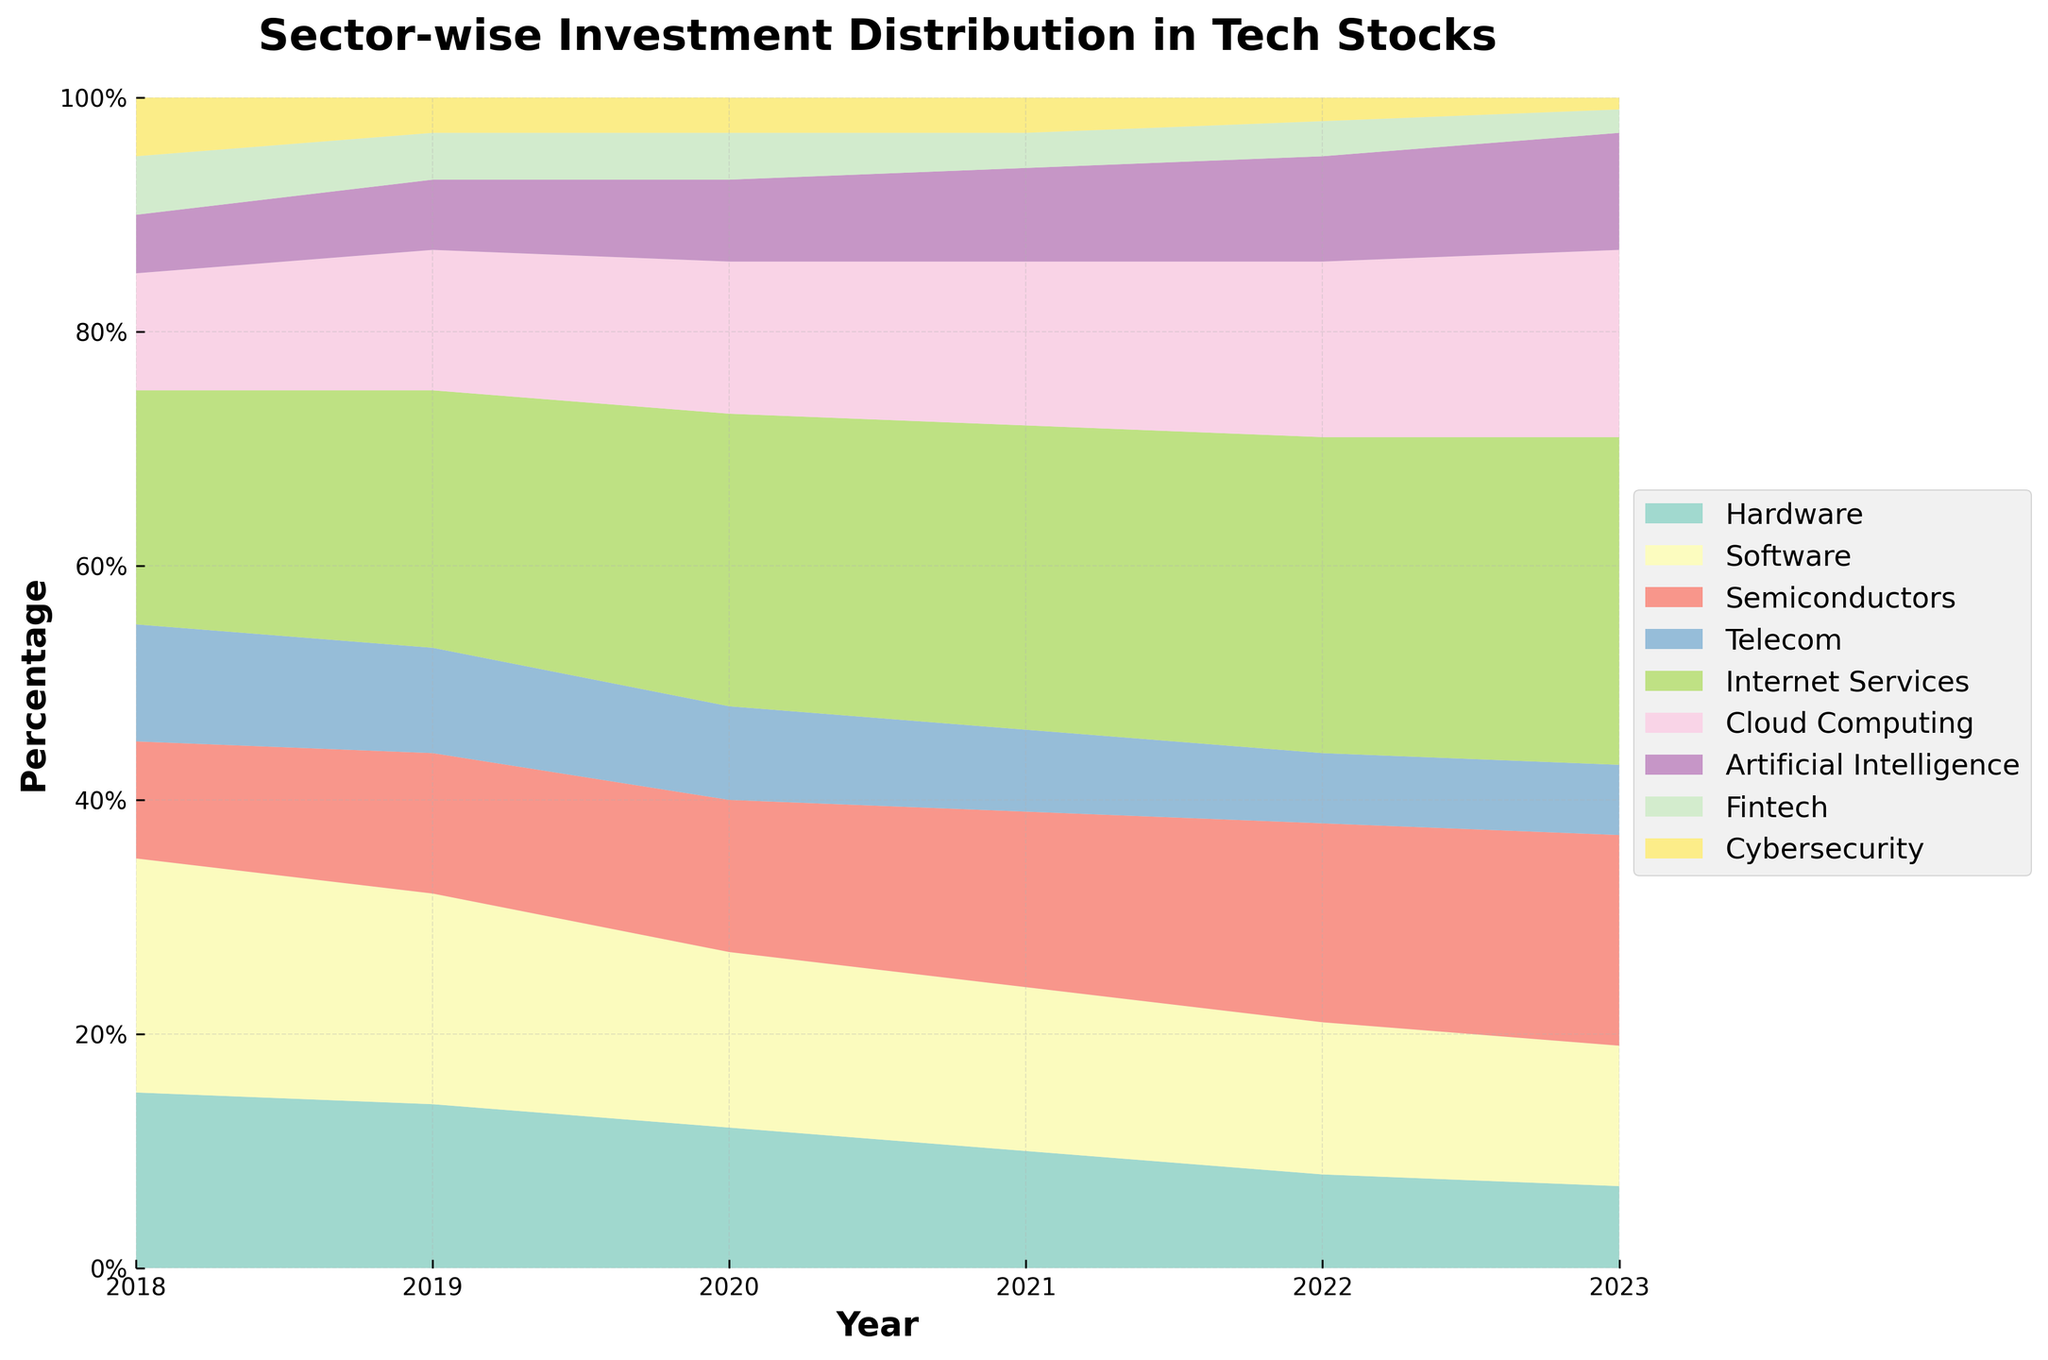What is the title of the plot? The title is located at the top of the plot and is written in bold font. It reads "Sector-wise Investment Distribution in Tech Stocks".
Answer: Sector-wise Investment Distribution in Tech Stocks Which sector had the highest percentage of investment in 2023? By looking at the width of the segments in the 2023 area, the Internet Services sector has the largest area, indicating the highest percentage.
Answer: Internet Services How did the investment in the Hardware sector change from 2018 to 2023? The Hardware sector started at 15% in 2018 and decreased steadily each year to 7% in 2023.
Answer: It decreased Which year saw the highest percentage of investment in the Semiconductor sector? The year 2023 had the widest segment for the Semiconductors sector, indicating it had the highest investment percentage that year.
Answer: 2023 What is the approximate percentage of investment in Cloud Computing in 2021? The Cloud Computing sector had a segment around 14% in 2021. By comparing the size of the segment with the y-axis, it seems to be around 14%.
Answer: 14% Compare the investment trends in Artificial Intelligence and Cybersecurity from 2018 to 2023. The Artificial Intelligence sector started at 5% in 2018 and increased to 10% by 2023. Cybersecurity started at 5% and decreased to 1% over the same period.
Answer: AI increased, Cybersecurity decreased Which year had the lowest percentage for the Telecom sector, and what was the percentage? The year 2023 shows the smallest segment for the Telecom sector, which seems to be around 6%.
Answer: 2023, 6% What is the overall trend for the Internet Services sector from 2018 to 2023? The Internet Services sector shows an overall increasing trend, starting at 20% in 2018 and rising to 28% in 2023.
Answer: Increasing trend Calculate the difference in investment percentage between Fintech and Cybersecurity in 2022. In 2022, Fintech had 3%, and Cybersecurity had 2%. The difference is 3% - 2% = 1%.
Answer: 1% What is the combined percentage of investment in Software and Hardware in 2020? In 2020, Software had 15%, and Hardware had 12%. The combined percentage is 15% + 12% = 27%.
Answer: 27% 